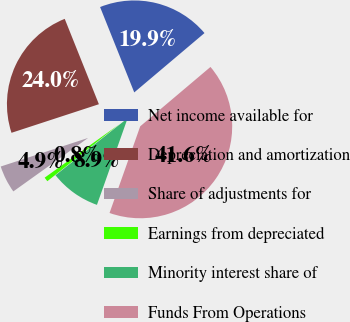Convert chart. <chart><loc_0><loc_0><loc_500><loc_500><pie_chart><fcel>Net income available for<fcel>Depreciation and amortization<fcel>Share of adjustments for<fcel>Earnings from depreciated<fcel>Minority interest share of<fcel>Funds From Operations<nl><fcel>19.89%<fcel>23.97%<fcel>4.85%<fcel>0.77%<fcel>8.93%<fcel>41.58%<nl></chart> 